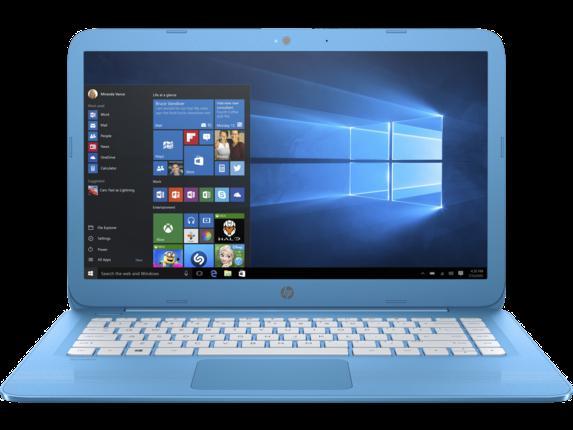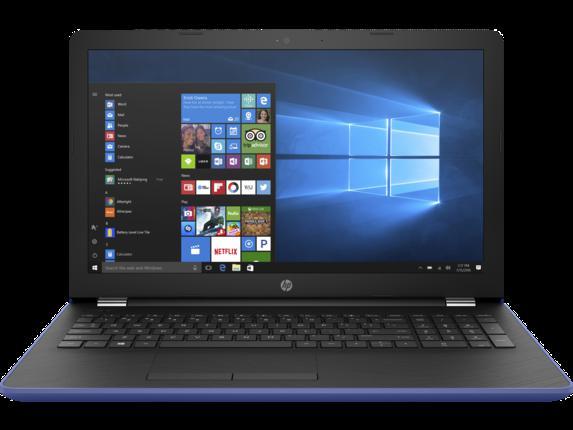The first image is the image on the left, the second image is the image on the right. Given the left and right images, does the statement "Two laptop computers facing front are open with start screens showing, but with different colored keyboards." hold true? Answer yes or no. Yes. The first image is the image on the left, the second image is the image on the right. Examine the images to the left and right. Is the description "Each open laptop is displayed head-on, and each screen contains a square with a black background on the left and glowing blue light that radiates leftward." accurate? Answer yes or no. Yes. 